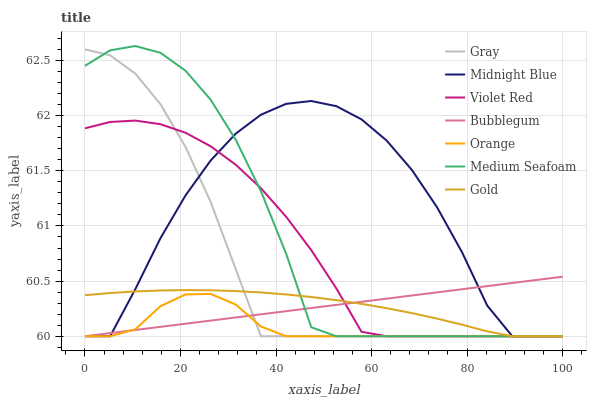Does Orange have the minimum area under the curve?
Answer yes or no. Yes. Does Midnight Blue have the maximum area under the curve?
Answer yes or no. Yes. Does Violet Red have the minimum area under the curve?
Answer yes or no. No. Does Violet Red have the maximum area under the curve?
Answer yes or no. No. Is Bubblegum the smoothest?
Answer yes or no. Yes. Is Midnight Blue the roughest?
Answer yes or no. Yes. Is Violet Red the smoothest?
Answer yes or no. No. Is Violet Red the roughest?
Answer yes or no. No. Does Gray have the lowest value?
Answer yes or no. Yes. Does Medium Seafoam have the highest value?
Answer yes or no. Yes. Does Violet Red have the highest value?
Answer yes or no. No. Does Bubblegum intersect Gold?
Answer yes or no. Yes. Is Bubblegum less than Gold?
Answer yes or no. No. Is Bubblegum greater than Gold?
Answer yes or no. No. 